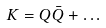Convert formula to latex. <formula><loc_0><loc_0><loc_500><loc_500>K = Q \bar { Q } + \dots</formula> 